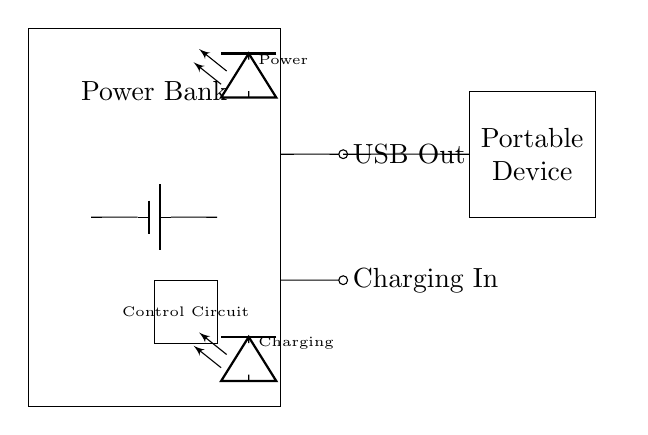What components are in the circuit? The circuit includes a power bank, battery, USB port, charging port, control circuit, power indicator LED, and charging indicator LED. These components are visually represented in the diagram.
Answer: power bank, battery, USB port, charging port, control circuit, power indicator, charging indicator What does the USB port do? The USB port serves as the output connection for charging a portable device. It is labeled "USB Out" which indicates its function to provide power to external devices.
Answer: Output Where is the control circuit located? The control circuit is located at the coordinates between x=2 and x=3, y=1 and y=2 within the power bank rectangle. It manages the circuitry functions for charging and powering devices.
Answer: Between the main section of the power bank What does the "Charging In" label indicate? The "Charging In" label indicates that this is the port where the power bank receives power for recharging its own battery. It is critical for the operation of the power bank.
Answer: Input What type of device is connected to the USB port? The USB port connects to a portable device, which is named in the diagram. The rectangle labeled as "Portable Device" shows where the device is connected for charging.
Answer: Portable device What do the LED indicators signify? The top LED labeled "Power" shows that the power bank is operational, while the bottom LED labeled "Charging" indicates that the battery is currently being charged. Together, these indicators inform the user of the power status.
Answer: Operational and charging status What key function does the battery serve in this circuit? The battery's key function is to store electrical energy and provide it to the portable device when connected via the USB port. It is the main energy source for the circuit's operation.
Answer: Energy storage and source 